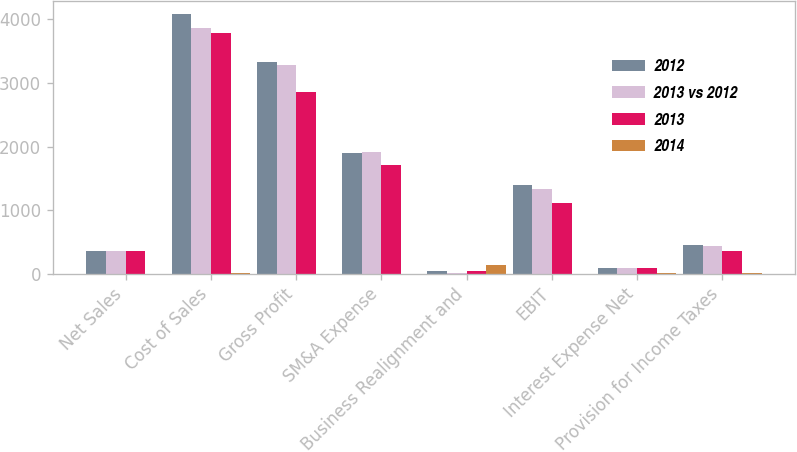<chart> <loc_0><loc_0><loc_500><loc_500><stacked_bar_chart><ecel><fcel>Net Sales<fcel>Cost of Sales<fcel>Gross Profit<fcel>SM&A Expense<fcel>Business Realignment and<fcel>EBIT<fcel>Interest Expense Net<fcel>Provision for Income Taxes<nl><fcel>2012<fcel>354.6<fcel>4085.6<fcel>3336.2<fcel>1901<fcel>45.6<fcel>1389.6<fcel>83.6<fcel>459.1<nl><fcel>2013 vs 2012<fcel>354.6<fcel>3865.2<fcel>3280.8<fcel>1922.5<fcel>18.6<fcel>1339.7<fcel>88.4<fcel>430.8<nl><fcel>2013<fcel>354.6<fcel>3784.4<fcel>2859.9<fcel>1703.8<fcel>45<fcel>1111.1<fcel>95.6<fcel>354.6<nl><fcel>2014<fcel>3.9<fcel>5.7<fcel>1.7<fcel>1.1<fcel>144.4<fcel>3.7<fcel>5.5<fcel>6.6<nl></chart> 